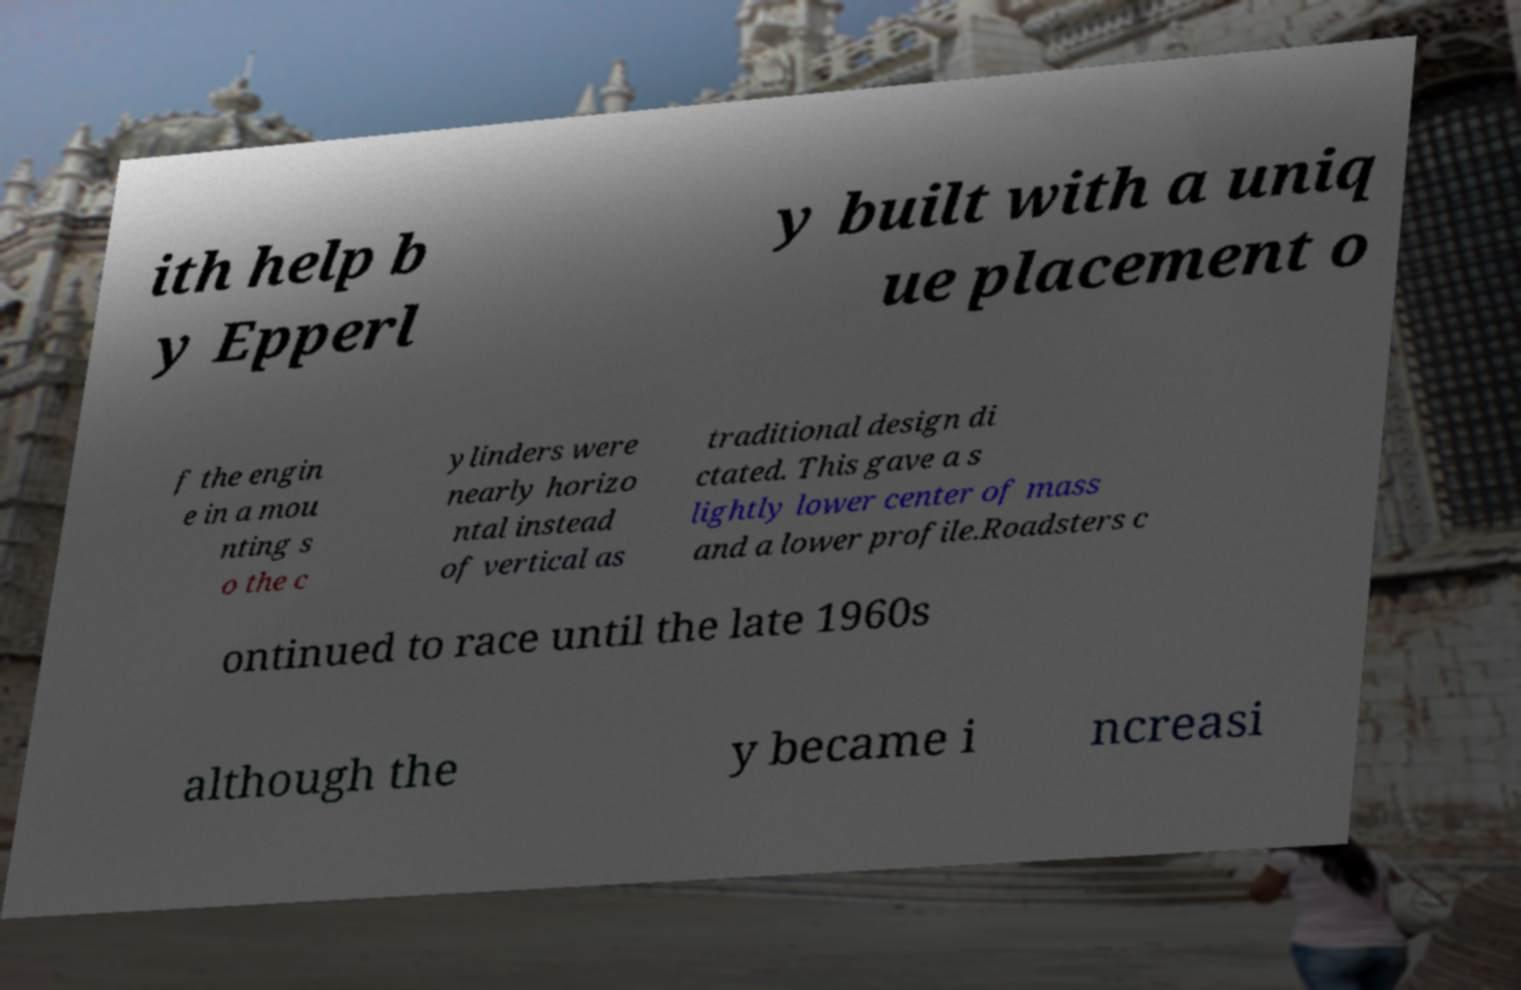Can you read and provide the text displayed in the image?This photo seems to have some interesting text. Can you extract and type it out for me? ith help b y Epperl y built with a uniq ue placement o f the engin e in a mou nting s o the c ylinders were nearly horizo ntal instead of vertical as traditional design di ctated. This gave a s lightly lower center of mass and a lower profile.Roadsters c ontinued to race until the late 1960s although the y became i ncreasi 